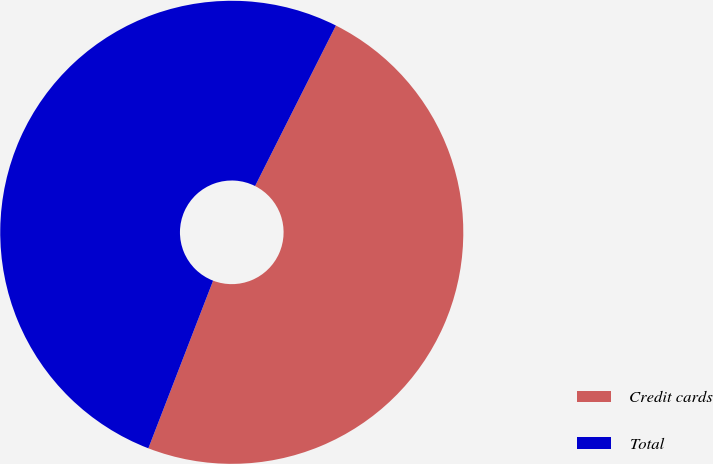Convert chart. <chart><loc_0><loc_0><loc_500><loc_500><pie_chart><fcel>Credit cards<fcel>Total<nl><fcel>48.44%<fcel>51.56%<nl></chart> 